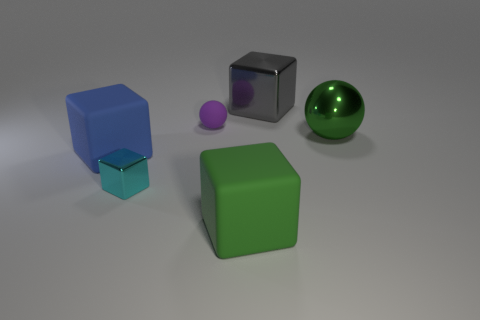Is the color of the ball that is right of the large gray block the same as the matte block that is right of the tiny cyan metallic block?
Offer a terse response. Yes. What size is the green metal thing in front of the large object behind the ball that is right of the green rubber thing?
Make the answer very short. Large. There is a large object that is behind the blue object and on the left side of the shiny ball; what shape is it?
Offer a very short reply. Cube. Are there an equal number of balls on the right side of the rubber ball and metal blocks to the right of the tiny metal block?
Make the answer very short. Yes. Are there any purple spheres made of the same material as the blue cube?
Your answer should be very brief. Yes. Are the green object that is to the left of the gray block and the cyan object made of the same material?
Ensure brevity in your answer.  No. How big is the metallic thing that is behind the large blue rubber thing and in front of the big gray thing?
Provide a succinct answer. Large. The tiny matte object has what color?
Keep it short and to the point. Purple. How many big gray blocks are there?
Your answer should be very brief. 1. What number of tiny matte objects are the same color as the big metallic sphere?
Give a very brief answer. 0. 